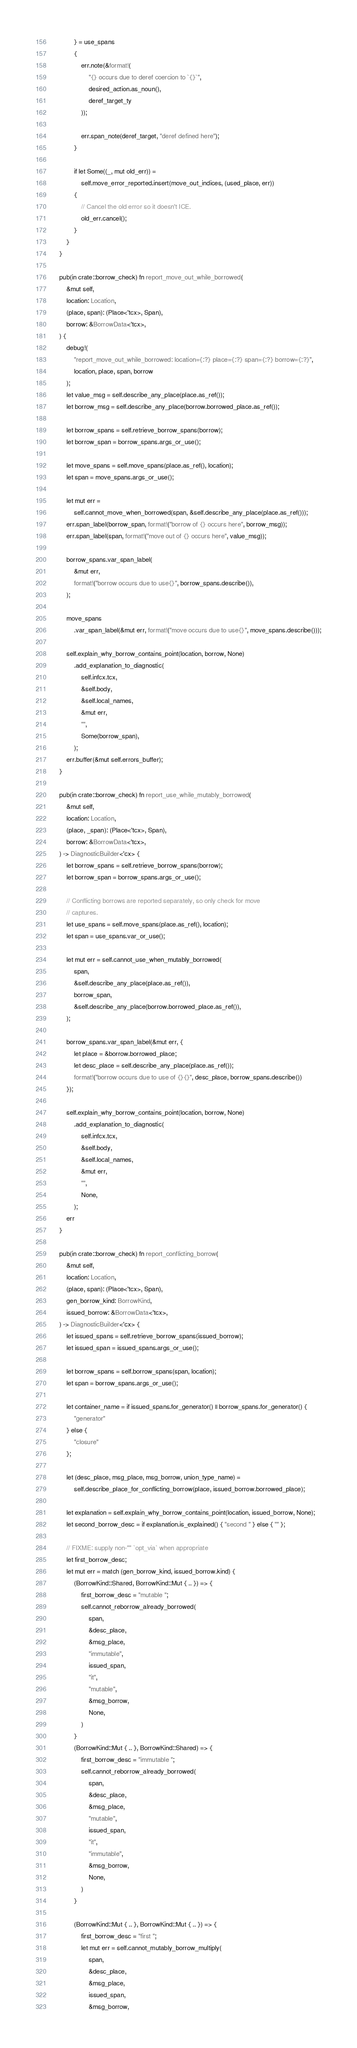Convert code to text. <code><loc_0><loc_0><loc_500><loc_500><_Rust_>            } = use_spans
            {
                err.note(&format!(
                    "{} occurs due to deref coercion to `{}`",
                    desired_action.as_noun(),
                    deref_target_ty
                ));

                err.span_note(deref_target, "deref defined here");
            }

            if let Some((_, mut old_err)) =
                self.move_error_reported.insert(move_out_indices, (used_place, err))
            {
                // Cancel the old error so it doesn't ICE.
                old_err.cancel();
            }
        }
    }

    pub(in crate::borrow_check) fn report_move_out_while_borrowed(
        &mut self,
        location: Location,
        (place, span): (Place<'tcx>, Span),
        borrow: &BorrowData<'tcx>,
    ) {
        debug!(
            "report_move_out_while_borrowed: location={:?} place={:?} span={:?} borrow={:?}",
            location, place, span, borrow
        );
        let value_msg = self.describe_any_place(place.as_ref());
        let borrow_msg = self.describe_any_place(borrow.borrowed_place.as_ref());

        let borrow_spans = self.retrieve_borrow_spans(borrow);
        let borrow_span = borrow_spans.args_or_use();

        let move_spans = self.move_spans(place.as_ref(), location);
        let span = move_spans.args_or_use();

        let mut err =
            self.cannot_move_when_borrowed(span, &self.describe_any_place(place.as_ref()));
        err.span_label(borrow_span, format!("borrow of {} occurs here", borrow_msg));
        err.span_label(span, format!("move out of {} occurs here", value_msg));

        borrow_spans.var_span_label(
            &mut err,
            format!("borrow occurs due to use{}", borrow_spans.describe()),
        );

        move_spans
            .var_span_label(&mut err, format!("move occurs due to use{}", move_spans.describe()));

        self.explain_why_borrow_contains_point(location, borrow, None)
            .add_explanation_to_diagnostic(
                self.infcx.tcx,
                &self.body,
                &self.local_names,
                &mut err,
                "",
                Some(borrow_span),
            );
        err.buffer(&mut self.errors_buffer);
    }

    pub(in crate::borrow_check) fn report_use_while_mutably_borrowed(
        &mut self,
        location: Location,
        (place, _span): (Place<'tcx>, Span),
        borrow: &BorrowData<'tcx>,
    ) -> DiagnosticBuilder<'cx> {
        let borrow_spans = self.retrieve_borrow_spans(borrow);
        let borrow_span = borrow_spans.args_or_use();

        // Conflicting borrows are reported separately, so only check for move
        // captures.
        let use_spans = self.move_spans(place.as_ref(), location);
        let span = use_spans.var_or_use();

        let mut err = self.cannot_use_when_mutably_borrowed(
            span,
            &self.describe_any_place(place.as_ref()),
            borrow_span,
            &self.describe_any_place(borrow.borrowed_place.as_ref()),
        );

        borrow_spans.var_span_label(&mut err, {
            let place = &borrow.borrowed_place;
            let desc_place = self.describe_any_place(place.as_ref());
            format!("borrow occurs due to use of {}{}", desc_place, borrow_spans.describe())
        });

        self.explain_why_borrow_contains_point(location, borrow, None)
            .add_explanation_to_diagnostic(
                self.infcx.tcx,
                &self.body,
                &self.local_names,
                &mut err,
                "",
                None,
            );
        err
    }

    pub(in crate::borrow_check) fn report_conflicting_borrow(
        &mut self,
        location: Location,
        (place, span): (Place<'tcx>, Span),
        gen_borrow_kind: BorrowKind,
        issued_borrow: &BorrowData<'tcx>,
    ) -> DiagnosticBuilder<'cx> {
        let issued_spans = self.retrieve_borrow_spans(issued_borrow);
        let issued_span = issued_spans.args_or_use();

        let borrow_spans = self.borrow_spans(span, location);
        let span = borrow_spans.args_or_use();

        let container_name = if issued_spans.for_generator() || borrow_spans.for_generator() {
            "generator"
        } else {
            "closure"
        };

        let (desc_place, msg_place, msg_borrow, union_type_name) =
            self.describe_place_for_conflicting_borrow(place, issued_borrow.borrowed_place);

        let explanation = self.explain_why_borrow_contains_point(location, issued_borrow, None);
        let second_borrow_desc = if explanation.is_explained() { "second " } else { "" };

        // FIXME: supply non-"" `opt_via` when appropriate
        let first_borrow_desc;
        let mut err = match (gen_borrow_kind, issued_borrow.kind) {
            (BorrowKind::Shared, BorrowKind::Mut { .. }) => {
                first_borrow_desc = "mutable ";
                self.cannot_reborrow_already_borrowed(
                    span,
                    &desc_place,
                    &msg_place,
                    "immutable",
                    issued_span,
                    "it",
                    "mutable",
                    &msg_borrow,
                    None,
                )
            }
            (BorrowKind::Mut { .. }, BorrowKind::Shared) => {
                first_borrow_desc = "immutable ";
                self.cannot_reborrow_already_borrowed(
                    span,
                    &desc_place,
                    &msg_place,
                    "mutable",
                    issued_span,
                    "it",
                    "immutable",
                    &msg_borrow,
                    None,
                )
            }

            (BorrowKind::Mut { .. }, BorrowKind::Mut { .. }) => {
                first_borrow_desc = "first ";
                let mut err = self.cannot_mutably_borrow_multiply(
                    span,
                    &desc_place,
                    &msg_place,
                    issued_span,
                    &msg_borrow,</code> 